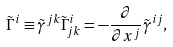<formula> <loc_0><loc_0><loc_500><loc_500>\tilde { \Gamma } ^ { i } \equiv \tilde { \gamma } ^ { j k } \tilde { \Gamma } ^ { i } _ { j k } = - \frac { \partial } { \partial x ^ { j } } \tilde { \gamma } ^ { i j } ,</formula> 